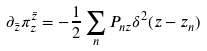<formula> <loc_0><loc_0><loc_500><loc_500>\partial _ { \bar { z } } \pi ^ { \bar { z } } _ { z } = - \frac { 1 } { 2 } \sum _ { n } P _ { n z } \delta ^ { 2 } ( z - z _ { n } )</formula> 